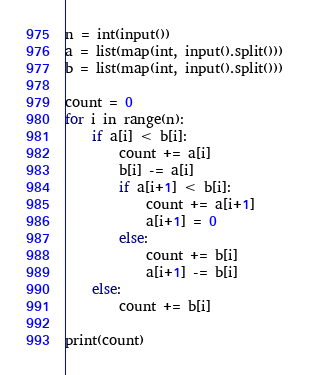<code> <loc_0><loc_0><loc_500><loc_500><_Python_>n = int(input())
a = list(map(int, input().split()))
b = list(map(int, input().split()))

count = 0
for i in range(n):
    if a[i] < b[i]:
        count += a[i]
        b[i] -= a[i]
        if a[i+1] < b[i]:
            count += a[i+1]
            a[i+1] = 0
        else:
            count += b[i]
            a[i+1] -= b[i]
    else:
        count += b[i]

print(count)
</code> 